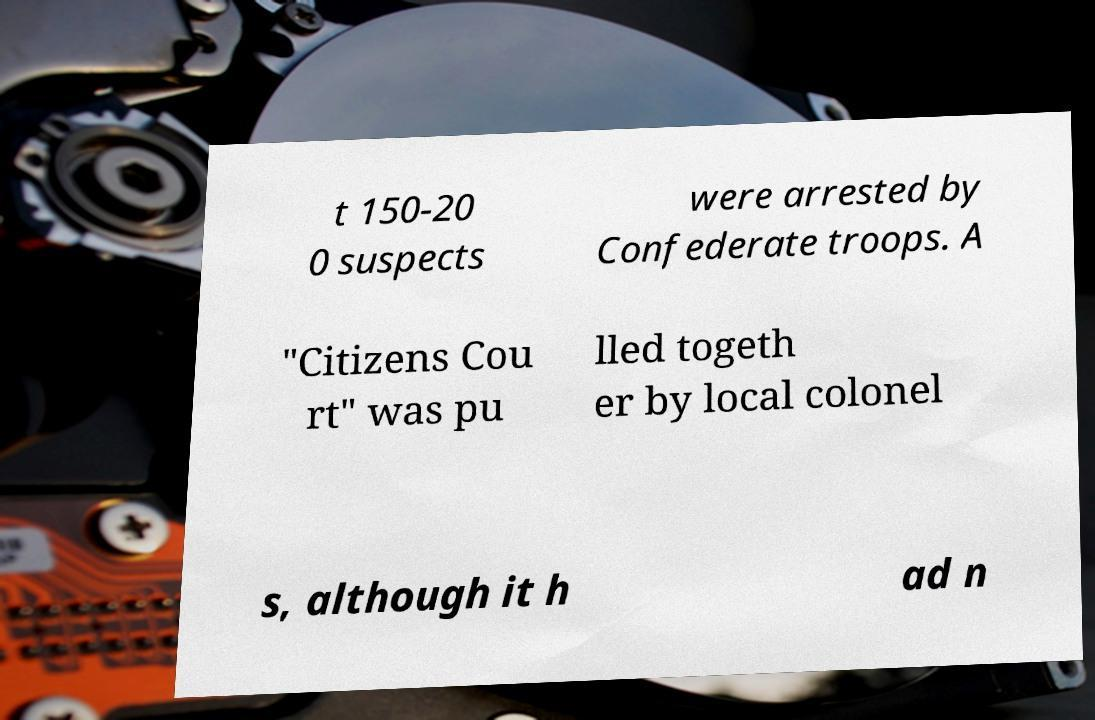Can you accurately transcribe the text from the provided image for me? t 150-20 0 suspects were arrested by Confederate troops. A "Citizens Cou rt" was pu lled togeth er by local colonel s, although it h ad n 